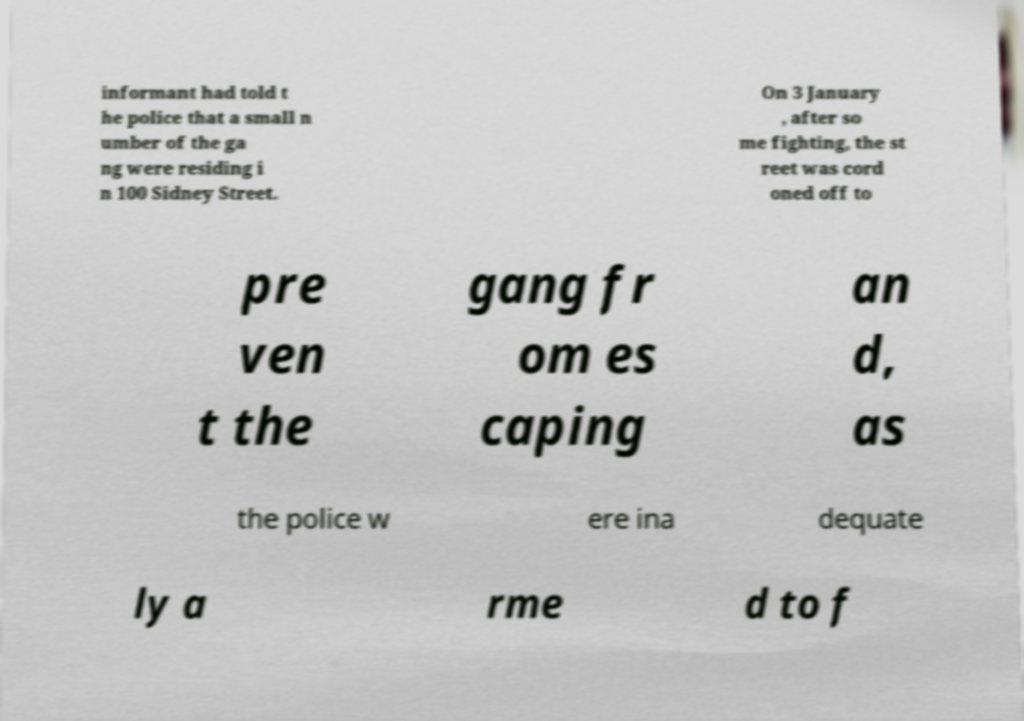Please identify and transcribe the text found in this image. informant had told t he police that a small n umber of the ga ng were residing i n 100 Sidney Street. On 3 January , after so me fighting, the st reet was cord oned off to pre ven t the gang fr om es caping an d, as the police w ere ina dequate ly a rme d to f 